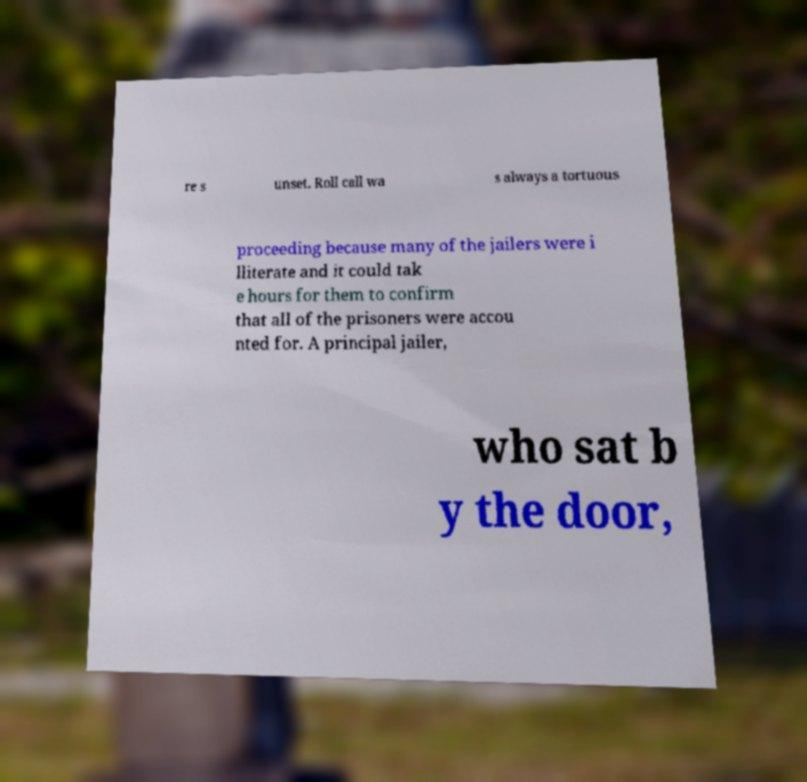Could you extract and type out the text from this image? re s unset. Roll call wa s always a tortuous proceeding because many of the jailers were i lliterate and it could tak e hours for them to confirm that all of the prisoners were accou nted for. A principal jailer, who sat b y the door, 